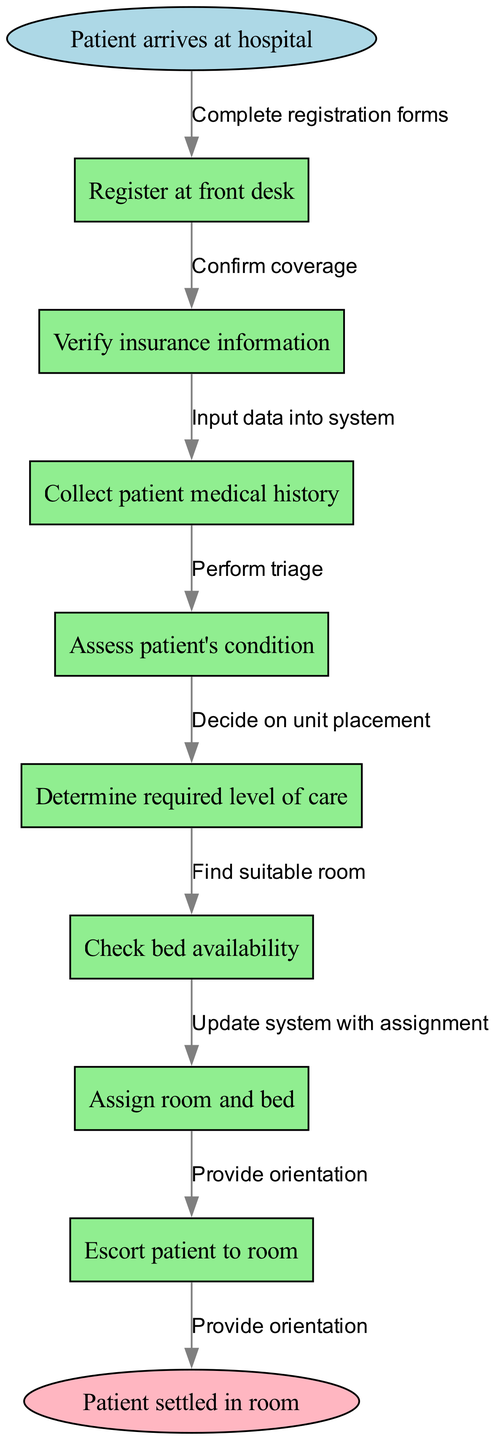What is the first step in the patient admission process? The first step in the process is indicated by the start node. According to the diagram, the start node states that "Patient arrives at hospital," which signifies the beginning of the sequence.
Answer: Patient arrives at hospital How many nodes are present in the diagram? The diagram comprises various nodes, including the start node, multiple process nodes, and the end node. Counting all these, there are 8 nodes in total: 1 start node + 7 process nodes + 1 end node.
Answer: 8 What is the last step in the patient admission process? The last step is represented by the end node, which indicates the conclusion of the process. The end node states "Patient settled in room," marking the final outcome of the admission process.
Answer: Patient settled in room What follows after verifying insurance information? To determine what comes next, we look at the flow from the node "Verify insurance information," which connects directly to the next node "Collect patient medical history." This reflects the progression of steps in the flowchart.
Answer: Collect patient medical history How many edges are in the diagram? The edges represent the connections between each step in the process. By counting the transitions from one node to another, including from the start to the first step and from the last step to the end node, we identify a total of 8 edges in the diagram.
Answer: 8 What is the relationship between assessing the patient's condition and determining the required level of care? The relationship between these two nodes shows a sequential dependency in the flowchart. After "Assess patient's condition," the next step in the flow is to "Determine required level of care," indicating that the assessment informs the decision about the care level needed.
Answer: Sequential dependency What action is taken after collecting the patient's medical history? After "Collect patient medical history," the flowchart indicates that "Assess patient's condition" is the next action. This means that the information gathered about the medical history is utilized in this subsequent step to evaluate the patient's current health status.
Answer: Assess patient's condition What does the final edge represent in the diagram? The final edge of the diagram connects the last process node "Assign room and bed" to the end node "Patient settled in room." This connection signifies the conclusion of the admission steps, indicating that after room assignment, the patient is directed to their room.
Answer: Patient settled in room 